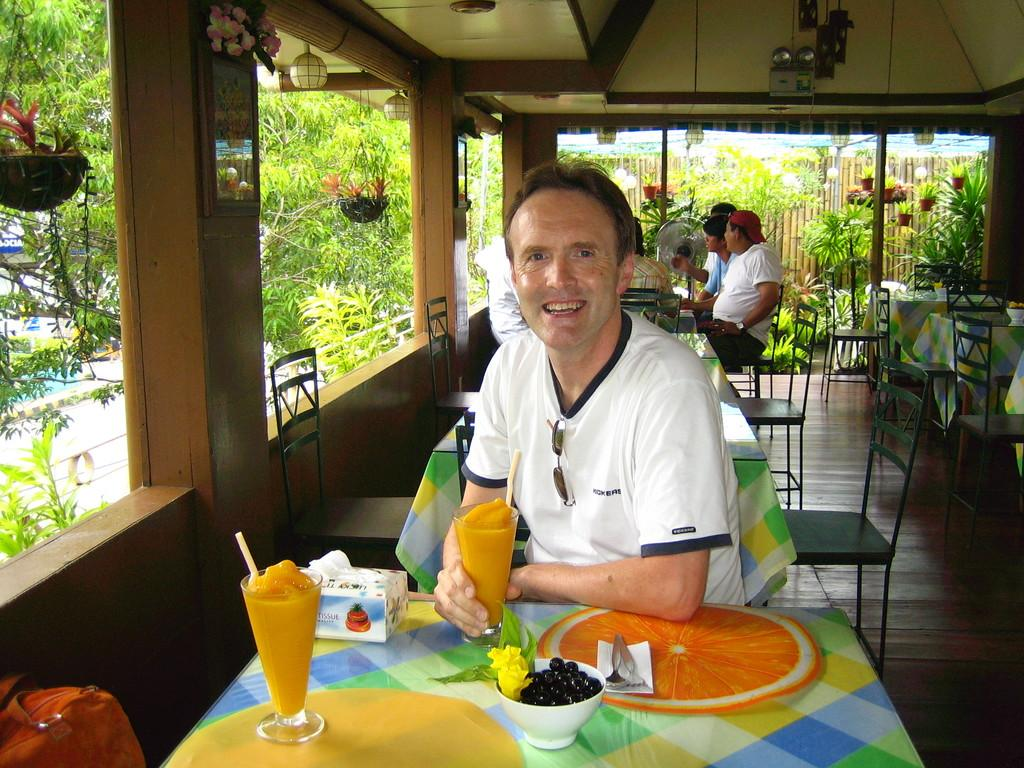What is the man in the image doing? The man is sitting in a chair in the image. What is in front of the man? The man is in front of a table in the image. What can be seen on the table? There are juice glasses, fruits, and a bowl on the table in the image. Is there anyone else in the image? Yes, there is another man sitting behind the first man in the image. What type of skirt is the judge wearing in the image? There is no judge or skirt present in the image. What is the home like where the scene takes place? The provided facts do not give any information about the home or its characteristics. 